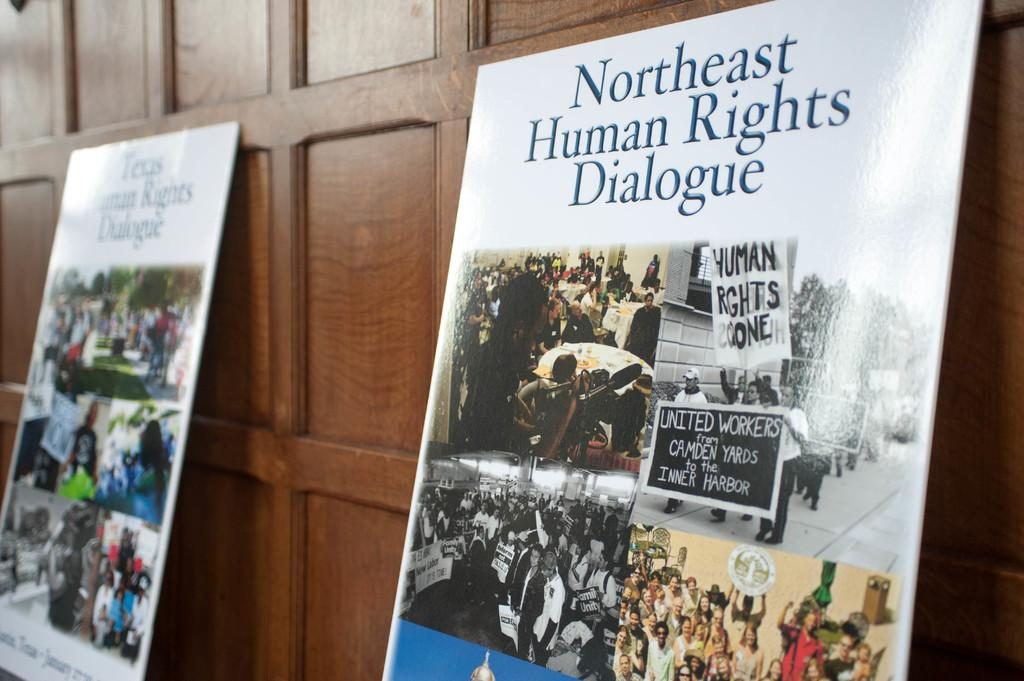<image>
Present a compact description of the photo's key features. A poster for the Northeast Human Rights Dialogue with pictures of protests and meetings leans against a wall. 